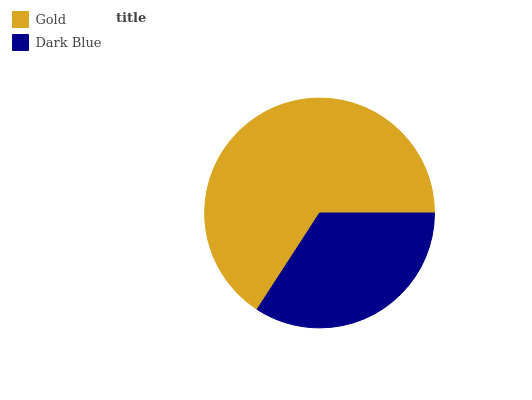Is Dark Blue the minimum?
Answer yes or no. Yes. Is Gold the maximum?
Answer yes or no. Yes. Is Dark Blue the maximum?
Answer yes or no. No. Is Gold greater than Dark Blue?
Answer yes or no. Yes. Is Dark Blue less than Gold?
Answer yes or no. Yes. Is Dark Blue greater than Gold?
Answer yes or no. No. Is Gold less than Dark Blue?
Answer yes or no. No. Is Gold the high median?
Answer yes or no. Yes. Is Dark Blue the low median?
Answer yes or no. Yes. Is Dark Blue the high median?
Answer yes or no. No. Is Gold the low median?
Answer yes or no. No. 